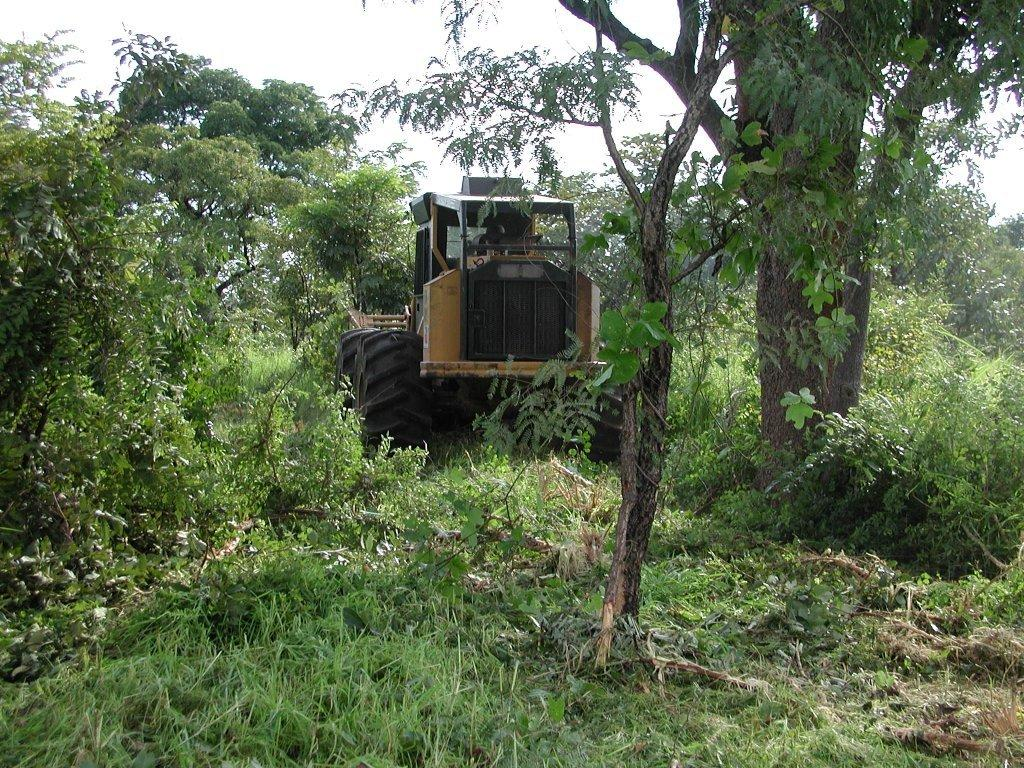What is the main subject in the image? There is a vehicle in the image. What type of natural elements can be seen in the image? There are trees and plants in the image. What is visible in the background of the image? The sky is visible in the image. What type of suit is the vehicle wearing in the image? Vehicles do not wear suits; they are inanimate objects. 